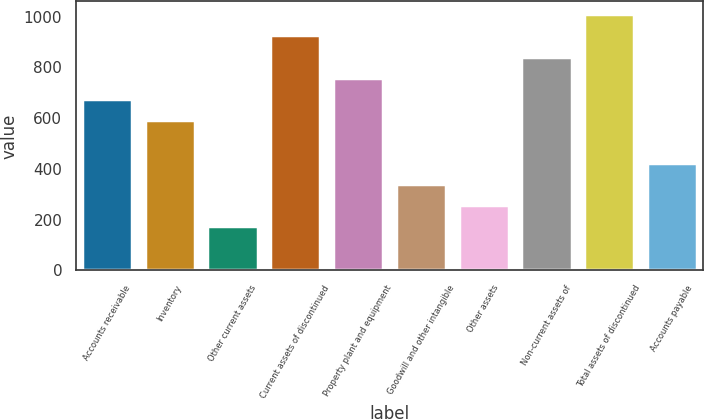Convert chart to OTSL. <chart><loc_0><loc_0><loc_500><loc_500><bar_chart><fcel>Accounts receivable<fcel>Inventory<fcel>Other current assets<fcel>Current assets of discontinued<fcel>Property plant and equipment<fcel>Goodwill and other intangible<fcel>Other assets<fcel>Non-current assets of<fcel>Total assets of discontinued<fcel>Accounts payable<nl><fcel>675<fcel>591.5<fcel>174<fcel>925.5<fcel>758.5<fcel>341<fcel>257.5<fcel>842<fcel>1009<fcel>424.5<nl></chart> 